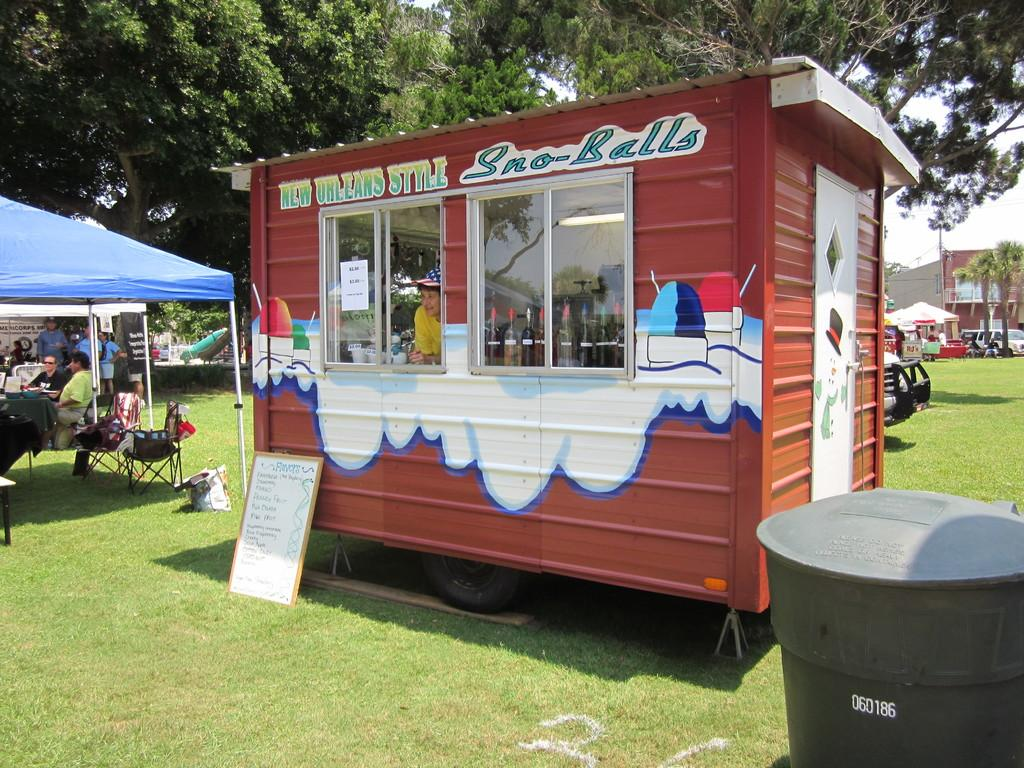<image>
Render a clear and concise summary of the photo. A little building sells New Orleans style Sno-balls. 